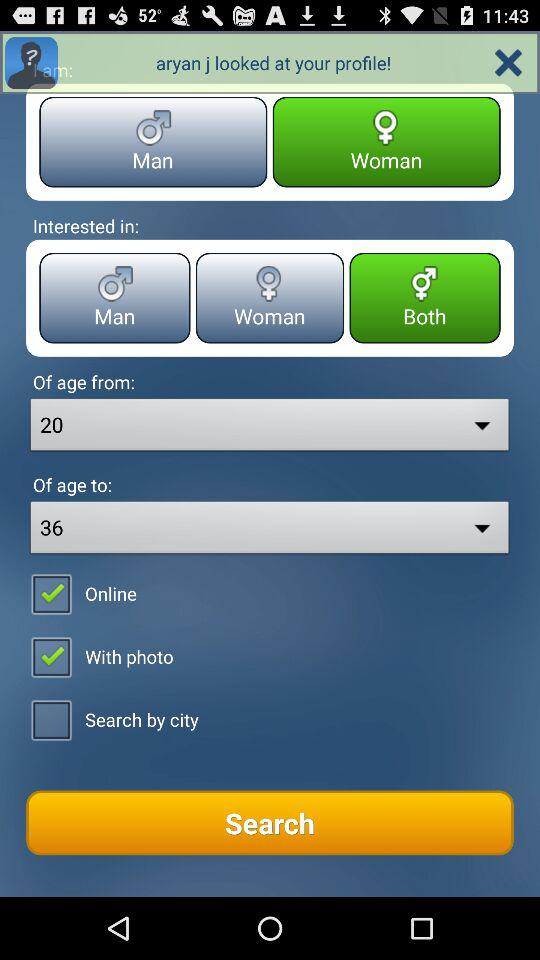Which option is not marked as checked? The option that is not marked as checked is "Search by city". 